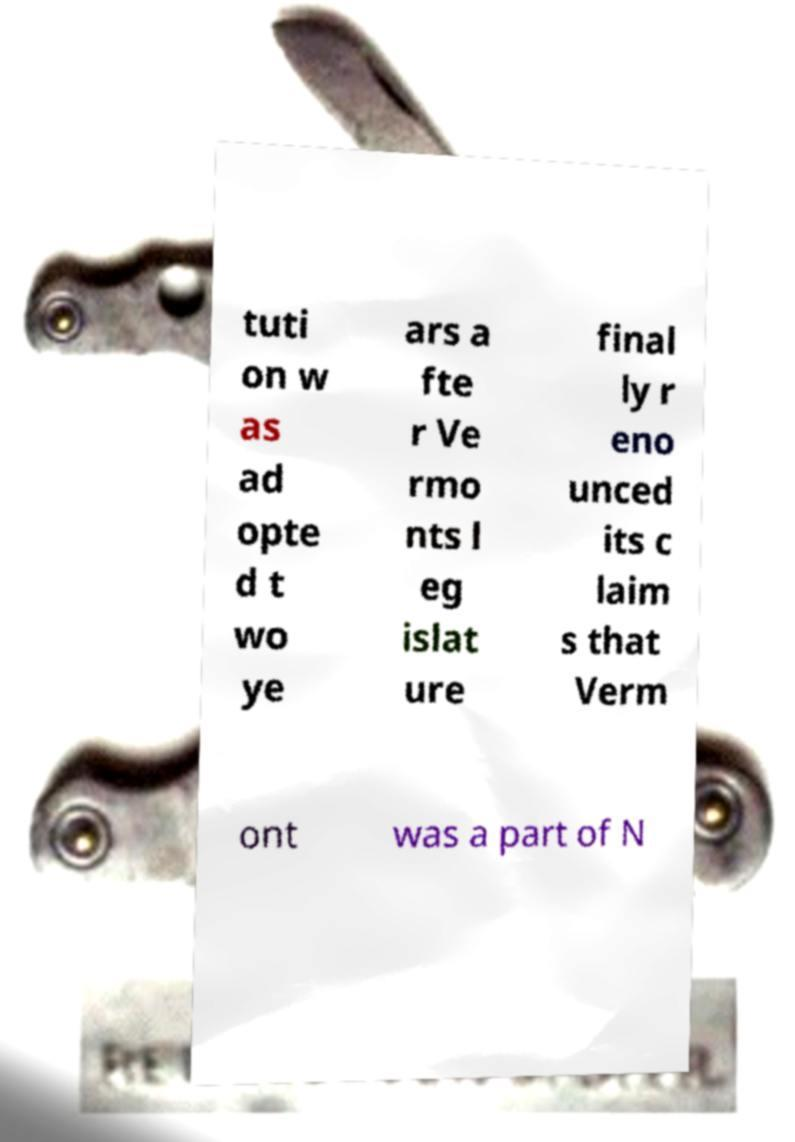I need the written content from this picture converted into text. Can you do that? tuti on w as ad opte d t wo ye ars a fte r Ve rmo nts l eg islat ure final ly r eno unced its c laim s that Verm ont was a part of N 